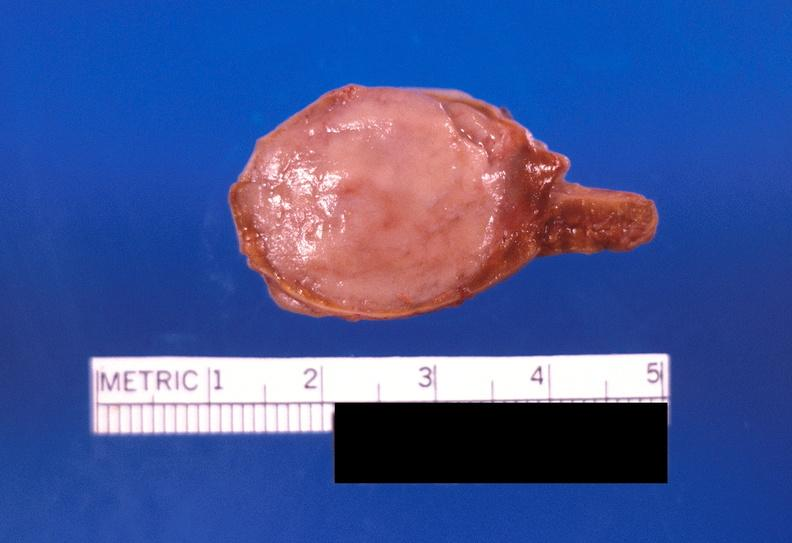what is present?
Answer the question using a single word or phrase. Endocrine 